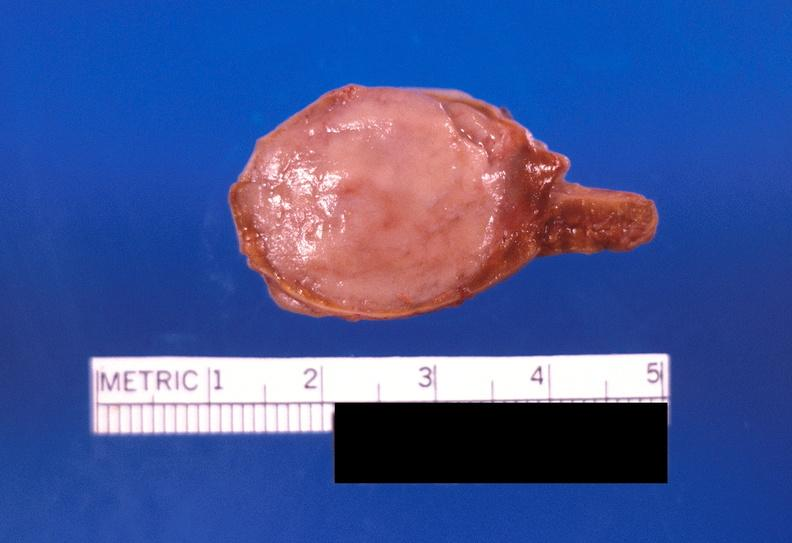what is present?
Answer the question using a single word or phrase. Endocrine 